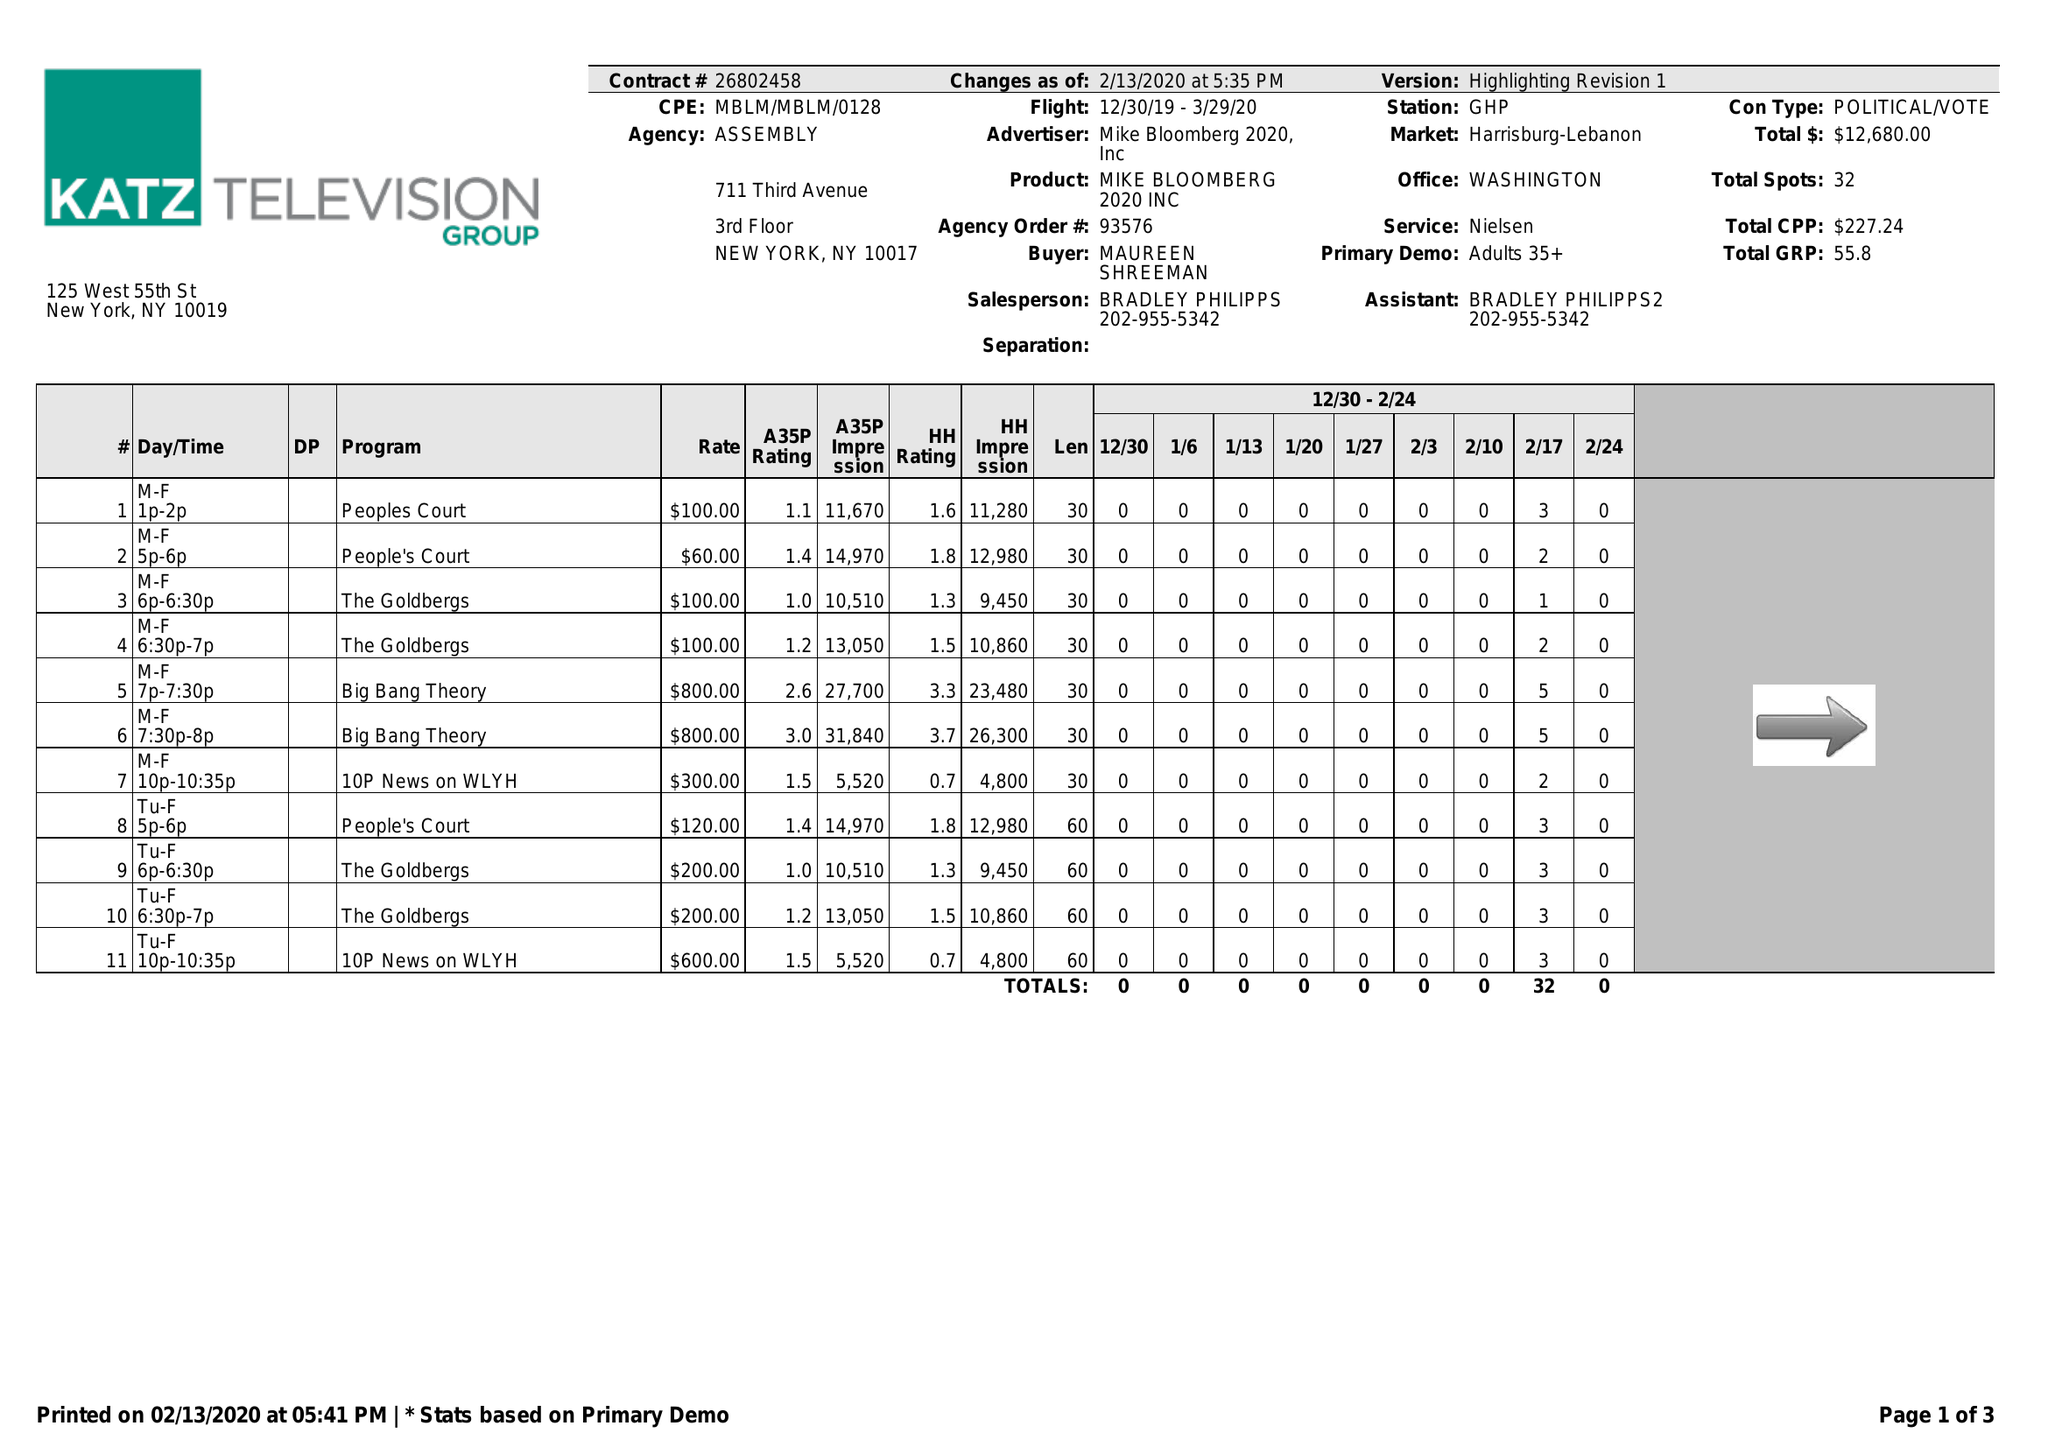What is the value for the flight_to?
Answer the question using a single word or phrase. 03/29/20 